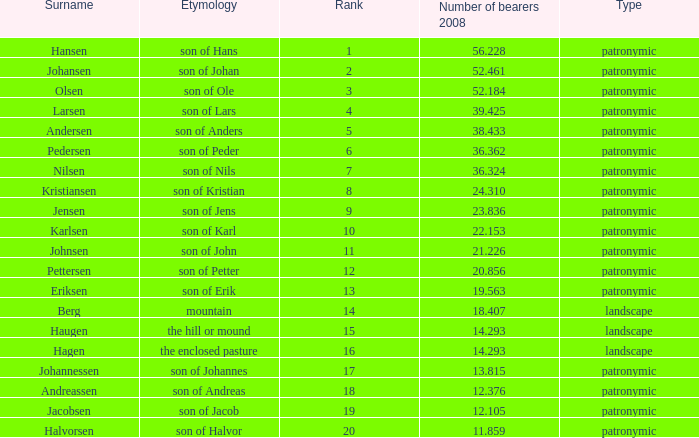What is Type, when Number of Bearers 2008 is greater than 12.376, when Rank is greater than 3, and when Etymology is Son of Jens? Patronymic. 